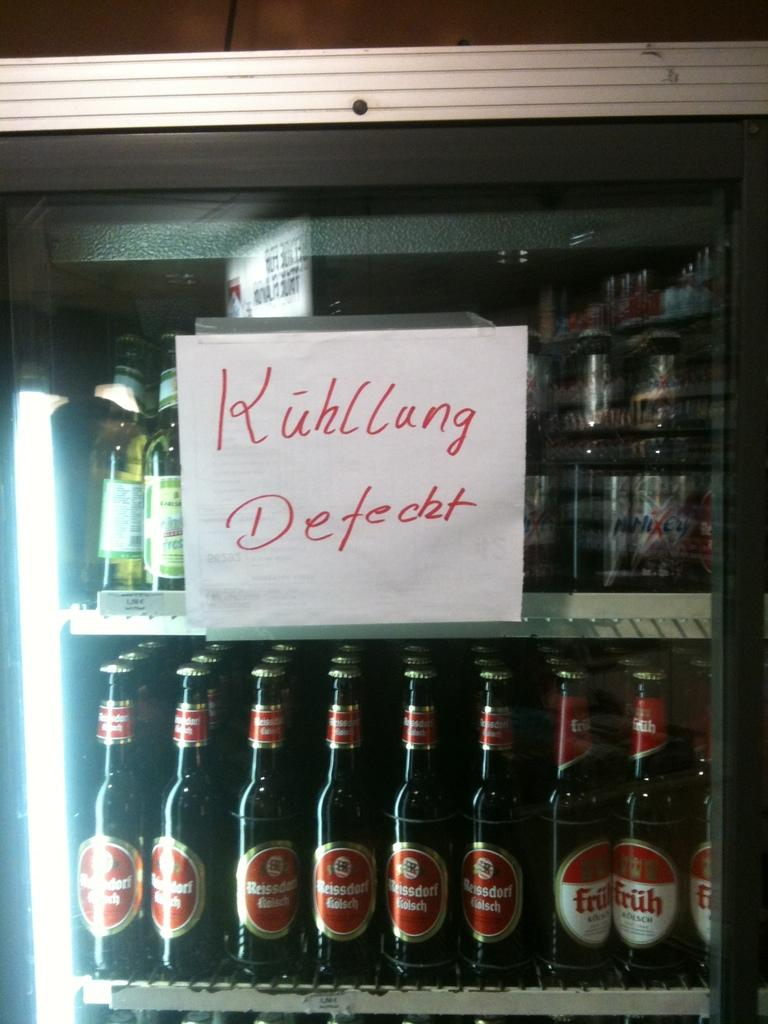<image>
Write a terse but informative summary of the picture. A cooler full of beer with a sign saying Kuhllun Defecht 